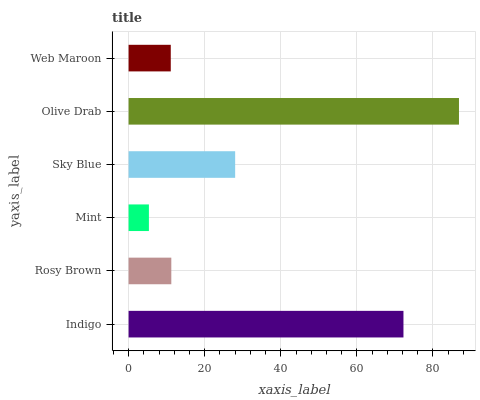Is Mint the minimum?
Answer yes or no. Yes. Is Olive Drab the maximum?
Answer yes or no. Yes. Is Rosy Brown the minimum?
Answer yes or no. No. Is Rosy Brown the maximum?
Answer yes or no. No. Is Indigo greater than Rosy Brown?
Answer yes or no. Yes. Is Rosy Brown less than Indigo?
Answer yes or no. Yes. Is Rosy Brown greater than Indigo?
Answer yes or no. No. Is Indigo less than Rosy Brown?
Answer yes or no. No. Is Sky Blue the high median?
Answer yes or no. Yes. Is Rosy Brown the low median?
Answer yes or no. Yes. Is Olive Drab the high median?
Answer yes or no. No. Is Indigo the low median?
Answer yes or no. No. 